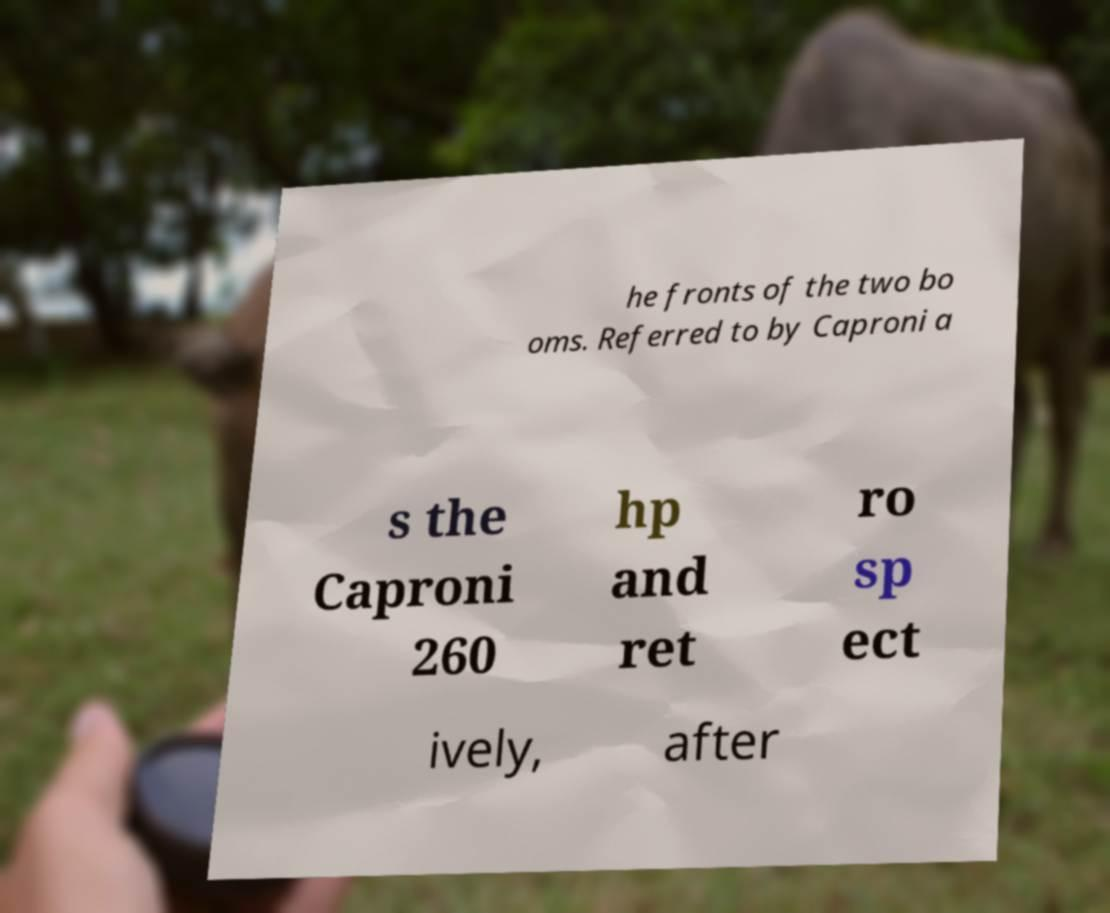For documentation purposes, I need the text within this image transcribed. Could you provide that? he fronts of the two bo oms. Referred to by Caproni a s the Caproni 260 hp and ret ro sp ect ively, after 